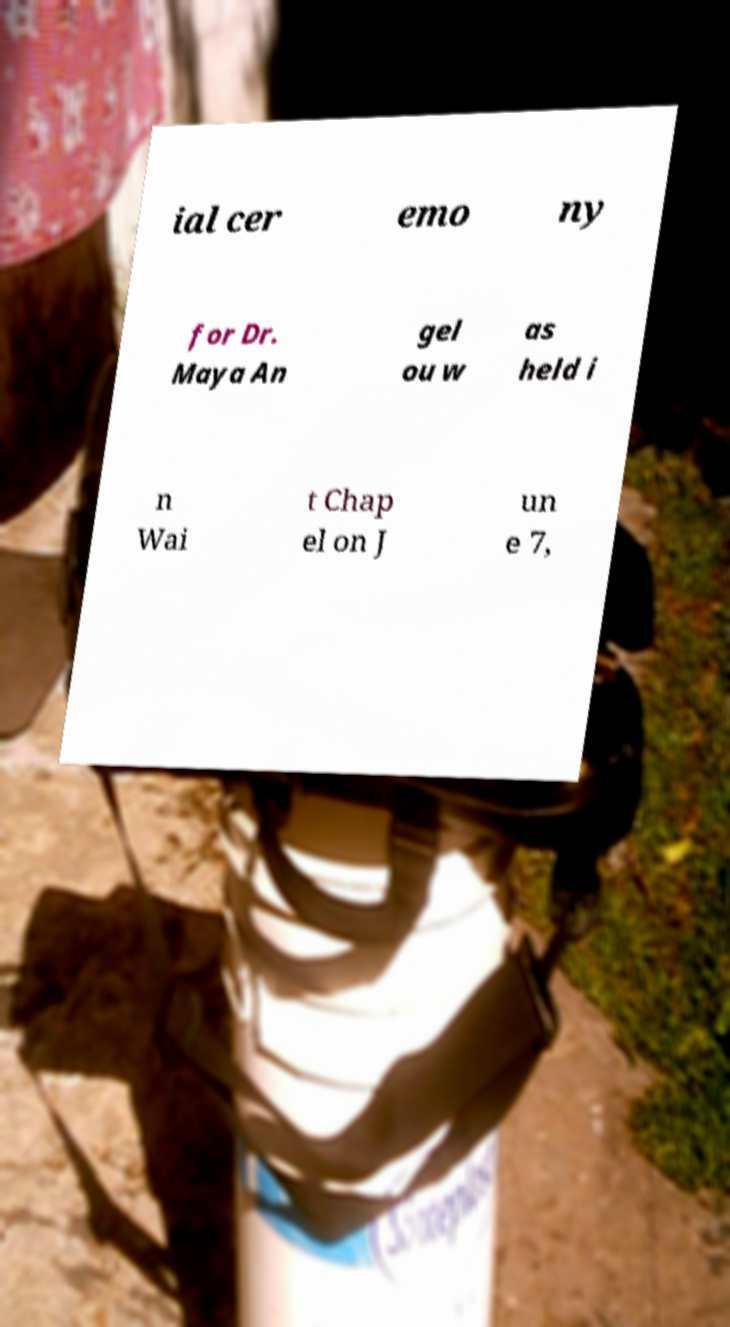Can you accurately transcribe the text from the provided image for me? ial cer emo ny for Dr. Maya An gel ou w as held i n Wai t Chap el on J un e 7, 